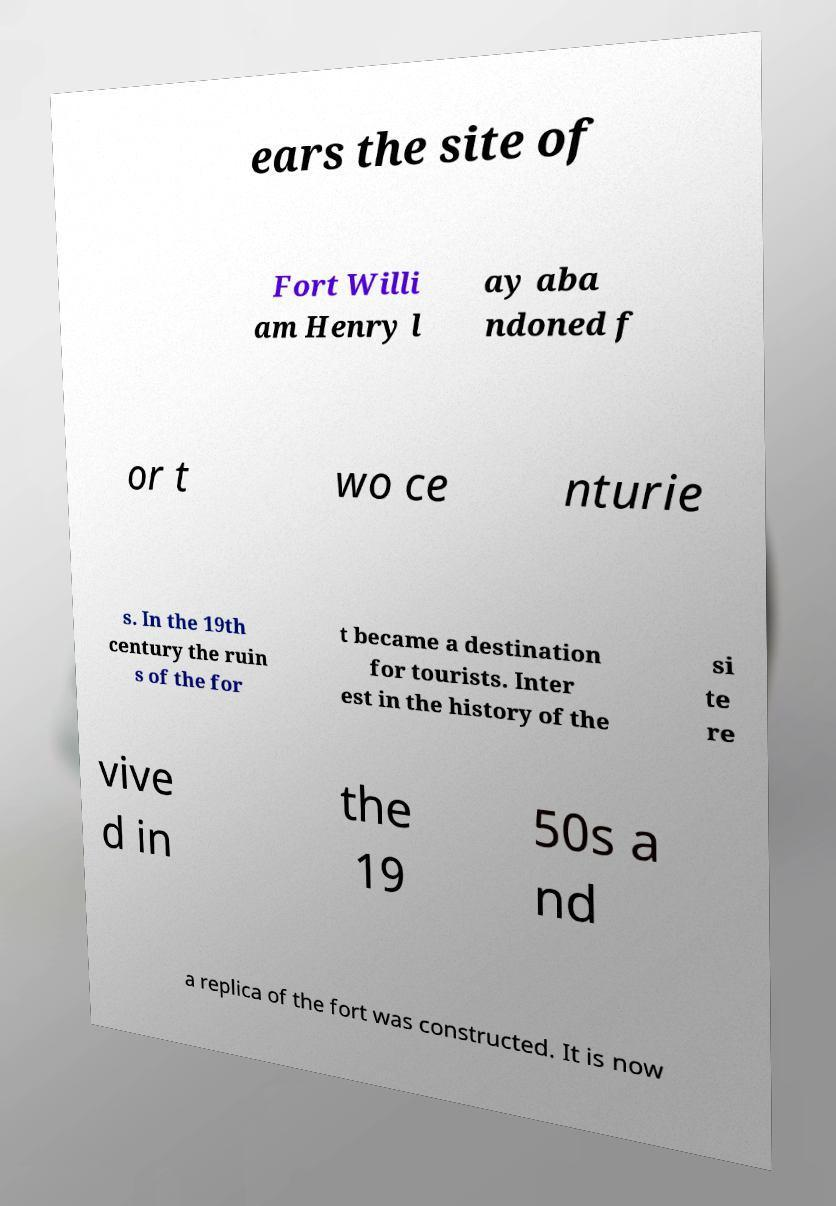Please read and relay the text visible in this image. What does it say? ears the site of Fort Willi am Henry l ay aba ndoned f or t wo ce nturie s. In the 19th century the ruin s of the for t became a destination for tourists. Inter est in the history of the si te re vive d in the 19 50s a nd a replica of the fort was constructed. It is now 